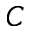<formula> <loc_0><loc_0><loc_500><loc_500>C</formula> 